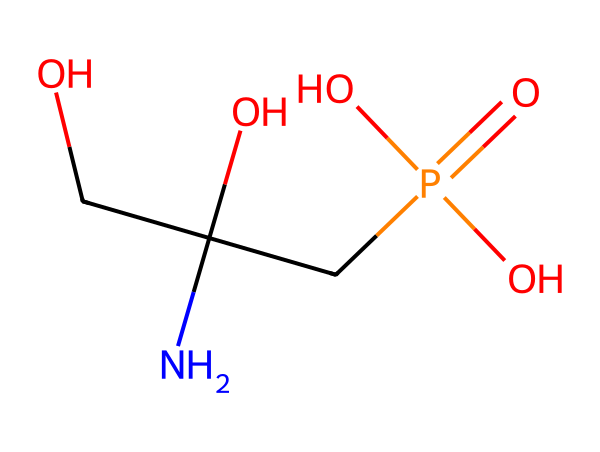What is the molecular formula of glyphosate? The molecular formula can be derived from the SMILES representation by counting the types of atoms present. The SMILES reveals carbon (C), hydrogen (H), oxygen (O), and phosphorus (P) atoms. Summing these gives C3, H11, N1, O4, P1, leading to the molecular formula C3H11NO4P.
Answer: C3H11NO4P How many carbon atoms are in glyphosate? The SMILES representation shows three carbon atoms indicated by the 'C' symbols. Thus, when counting these directly, we can conclude there are three carbon atoms.
Answer: 3 What functional group is present in glyphosate? Upon examining the SMILES, we notice the presence of a phosphonic acid functional group (indicated by the phosphorus atom attached to oxygen atoms). The structure contains a phosphorus atom double bonded to an oxygen atom (P=O) and to three -OH groups, confirming it is indeed a phosphonic acid.
Answer: phosphonic acid What is the total number of oxygen atoms in glyphosate? By analyzing the SMILES representation, we can identify four oxygen atoms, which helps determine the total. There are three -OH groups and one P=O bond, leading to a total of four oxygen atoms.
Answer: 4 How many nitrogen atoms are in glyphosate? Observing the SMILES, we see a single nitrogen symbol (N), indicating that there is one nitrogen atom present in the glyphosate molecule.
Answer: 1 Why is glyphosate classified as a herbicide? Glyphosate's structure, which contains specific functional groups like the amino group (NH) and phosphonic acid derivative, enables it to inhibit certain enzymes only found in plants and some microorganisms, impacting their growth. This property classifies it as a herbicide.
Answer: inhibits plant growth What type of interactions might glyphosate have with target proteins? The molecular structure suggests that glyphosate could form hydrogen bonds due to its -OH groups and Basic Amine, allowing it to interact with target proteins in plants, which is fundamental for its herbicidal activity.
Answer: hydrogen bonds 